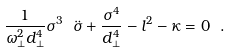<formula> <loc_0><loc_0><loc_500><loc_500>\frac { 1 } { \omega _ { \perp } ^ { 2 } d _ { \perp } ^ { 4 } } \sigma ^ { 3 } \ \ddot { \sigma } + \frac { \sigma ^ { 4 } } { d _ { \perp } ^ { 4 } } - l ^ { 2 } - \kappa = 0 \ .</formula> 